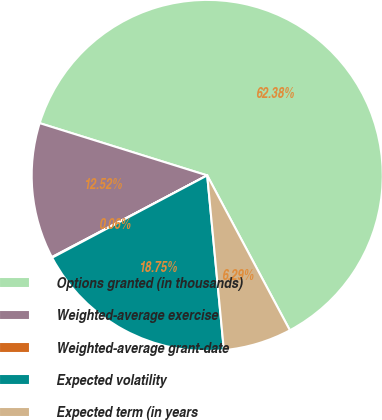Convert chart to OTSL. <chart><loc_0><loc_0><loc_500><loc_500><pie_chart><fcel>Options granted (in thousands)<fcel>Weighted-average exercise<fcel>Weighted-average grant-date<fcel>Expected volatility<fcel>Expected term (in years<nl><fcel>62.38%<fcel>12.52%<fcel>0.06%<fcel>18.75%<fcel>6.29%<nl></chart> 